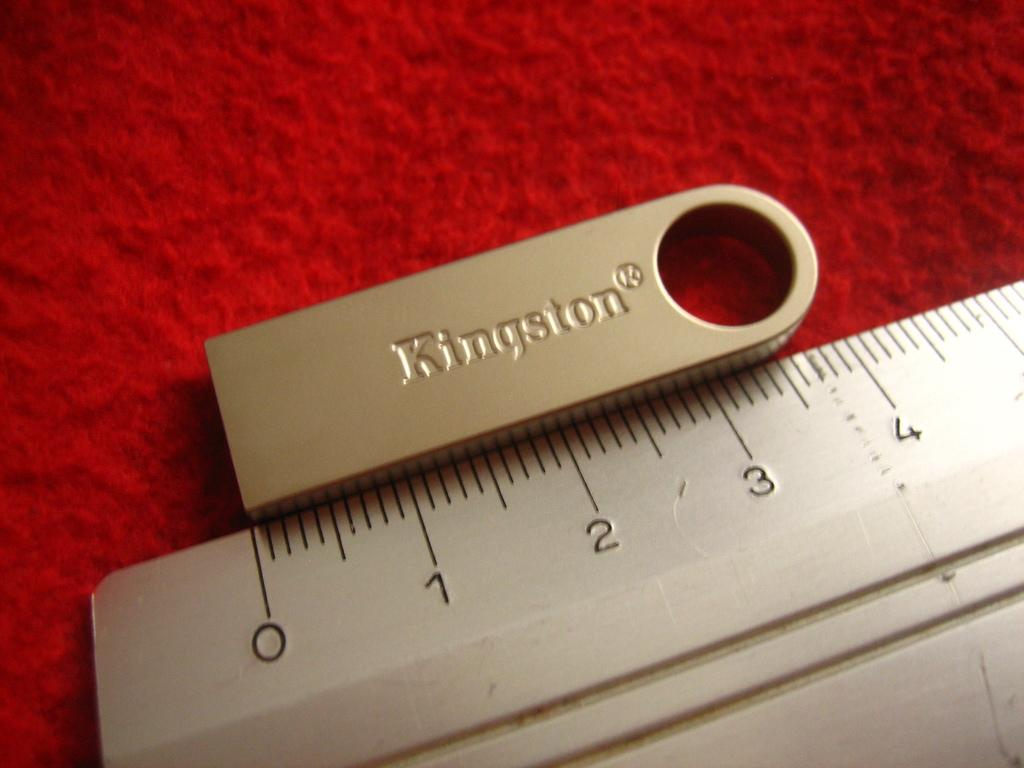<image>
Share a concise interpretation of the image provided. A ruler with a metal piece with Kingston engraved in it above it. 